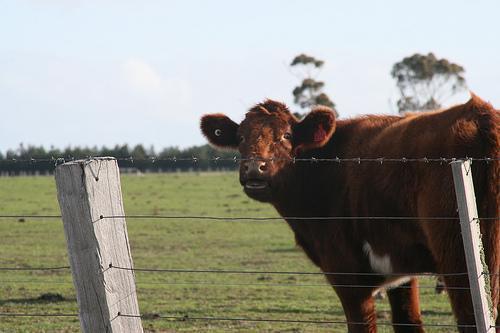How many cows are there?
Give a very brief answer. 1. How many tall trees are there?
Give a very brief answer. 2. How many fence posts are pictured?
Give a very brief answer. 2. 